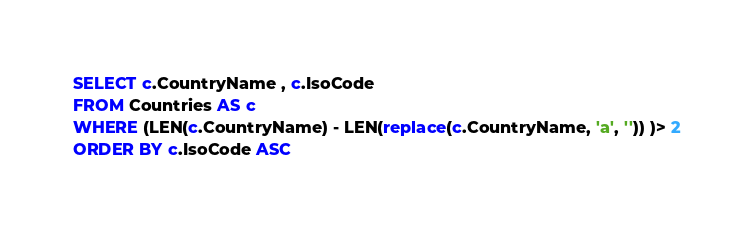<code> <loc_0><loc_0><loc_500><loc_500><_SQL_>
SELECT c.CountryName , c.IsoCode
FROM Countries AS c
WHERE (LEN(c.CountryName) - LEN(replace(c.CountryName, 'a', '')) )> 2
ORDER BY c.IsoCode ASC</code> 